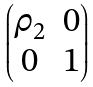Convert formula to latex. <formula><loc_0><loc_0><loc_500><loc_500>\begin{pmatrix} \rho _ { 2 } & 0 \\ 0 & 1 \end{pmatrix}</formula> 